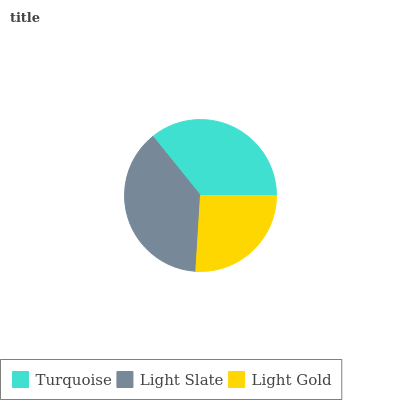Is Light Gold the minimum?
Answer yes or no. Yes. Is Light Slate the maximum?
Answer yes or no. Yes. Is Light Slate the minimum?
Answer yes or no. No. Is Light Gold the maximum?
Answer yes or no. No. Is Light Slate greater than Light Gold?
Answer yes or no. Yes. Is Light Gold less than Light Slate?
Answer yes or no. Yes. Is Light Gold greater than Light Slate?
Answer yes or no. No. Is Light Slate less than Light Gold?
Answer yes or no. No. Is Turquoise the high median?
Answer yes or no. Yes. Is Turquoise the low median?
Answer yes or no. Yes. Is Light Slate the high median?
Answer yes or no. No. Is Light Gold the low median?
Answer yes or no. No. 